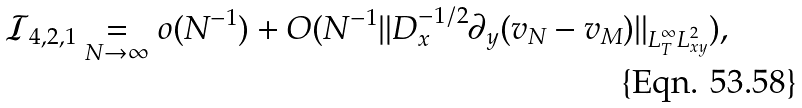<formula> <loc_0><loc_0><loc_500><loc_500>\mathcal { I } _ { 4 , 2 , 1 } \underset { N \to \infty } { = } o ( N ^ { - 1 } ) + O ( N ^ { - 1 } \| D _ { x } ^ { - 1 / 2 } \partial _ { y } ( v _ { N } - v _ { M } ) \| _ { L ^ { \infty } _ { T } L ^ { 2 } _ { x y } } ) ,</formula> 